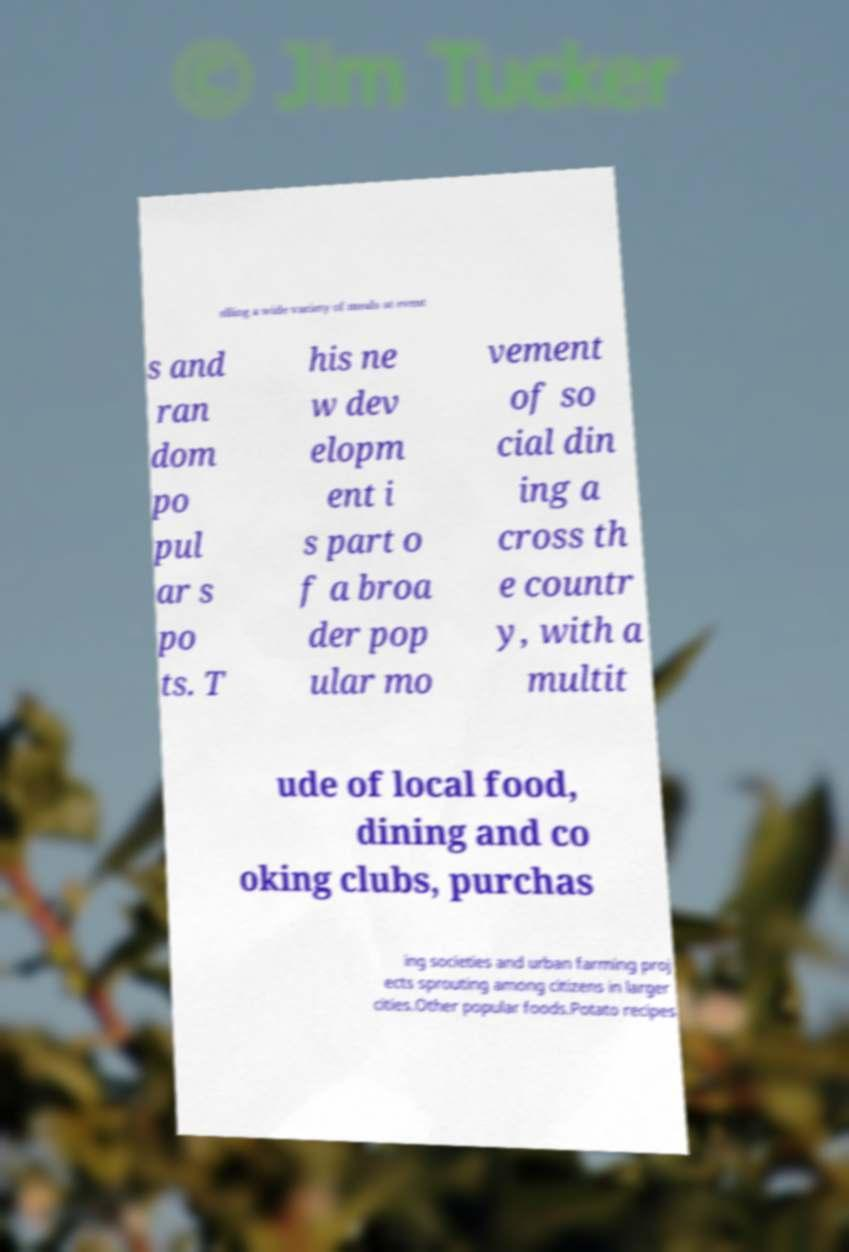For documentation purposes, I need the text within this image transcribed. Could you provide that? elling a wide variety of meals at event s and ran dom po pul ar s po ts. T his ne w dev elopm ent i s part o f a broa der pop ular mo vement of so cial din ing a cross th e countr y, with a multit ude of local food, dining and co oking clubs, purchas ing societies and urban farming proj ects sprouting among citizens in larger cities.Other popular foods.Potato recipes 